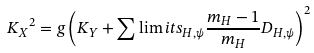Convert formula to latex. <formula><loc_0><loc_0><loc_500><loc_500>{ K _ { X } } ^ { 2 } = g \left ( K _ { Y } + \sum \lim i t s _ { H , \psi } { \frac { m _ { H } - 1 } { m _ { H } } D _ { H , \psi } } \right ) ^ { 2 }</formula> 